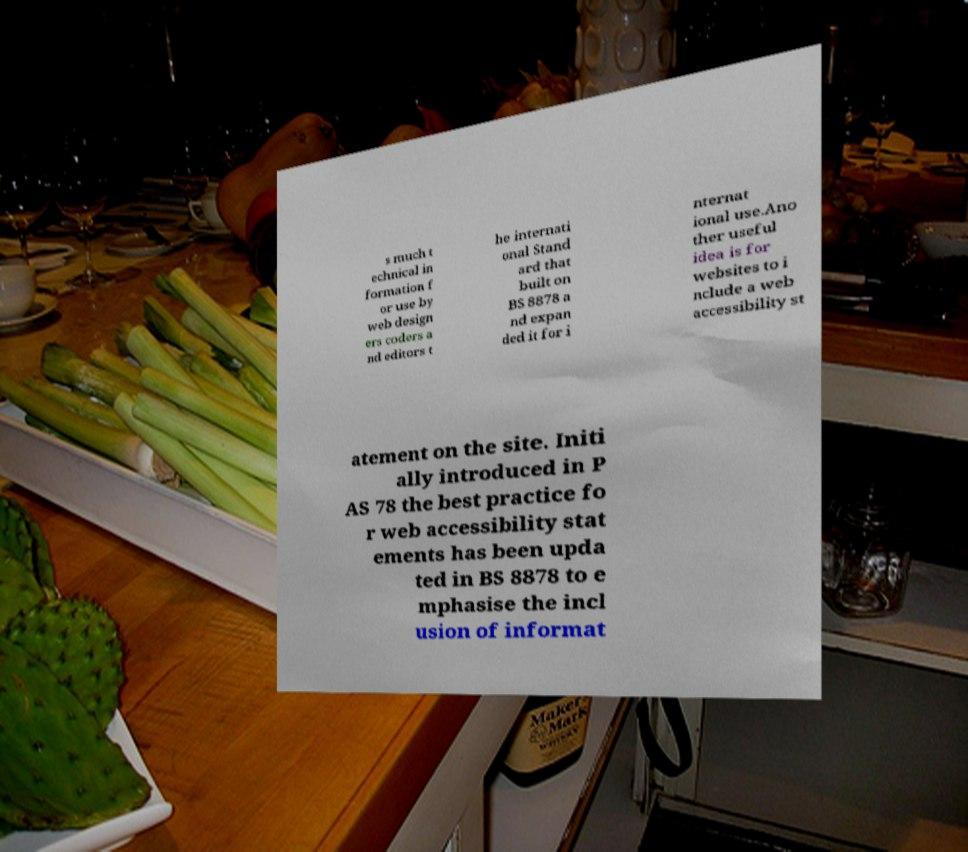Can you accurately transcribe the text from the provided image for me? s much t echnical in formation f or use by web design ers coders a nd editors t he internati onal Stand ard that built on BS 8878 a nd expan ded it for i nternat ional use.Ano ther useful idea is for websites to i nclude a web accessibility st atement on the site. Initi ally introduced in P AS 78 the best practice fo r web accessibility stat ements has been upda ted in BS 8878 to e mphasise the incl usion of informat 